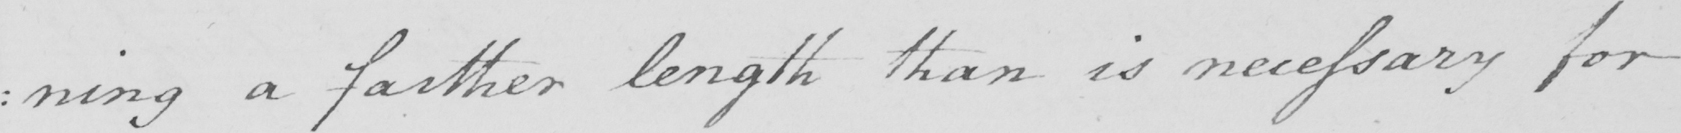Transcribe the text shown in this historical manuscript line. : ning a farther length than is necessary for 